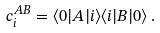Convert formula to latex. <formula><loc_0><loc_0><loc_500><loc_500>c _ { i } ^ { A B } = \langle 0 | A | i \rangle \langle i | B | 0 \rangle \, .</formula> 